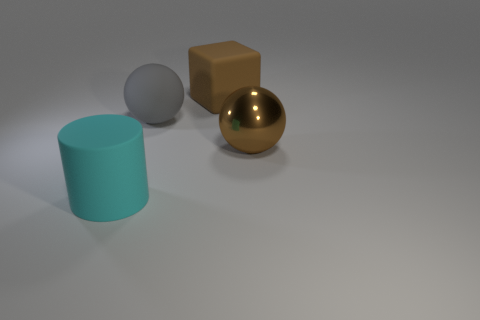Add 3 large green matte blocks. How many objects exist? 7 Subtract all cylinders. How many objects are left? 3 Subtract all matte balls. Subtract all brown metal spheres. How many objects are left? 2 Add 2 big brown rubber cubes. How many big brown rubber cubes are left? 3 Add 3 small gray metallic blocks. How many small gray metallic blocks exist? 3 Subtract 1 cyan cylinders. How many objects are left? 3 